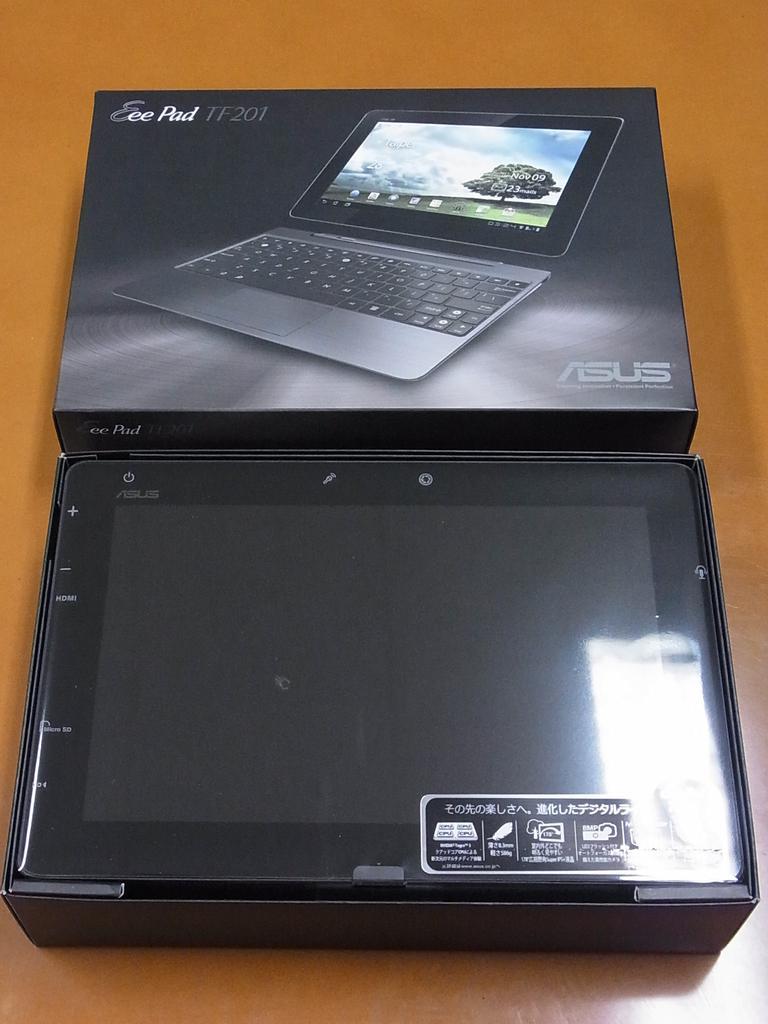In one or two sentences, can you explain what this image depicts? In this image, we can see a box contains a tablet. There is an another box in the middle of the image. 